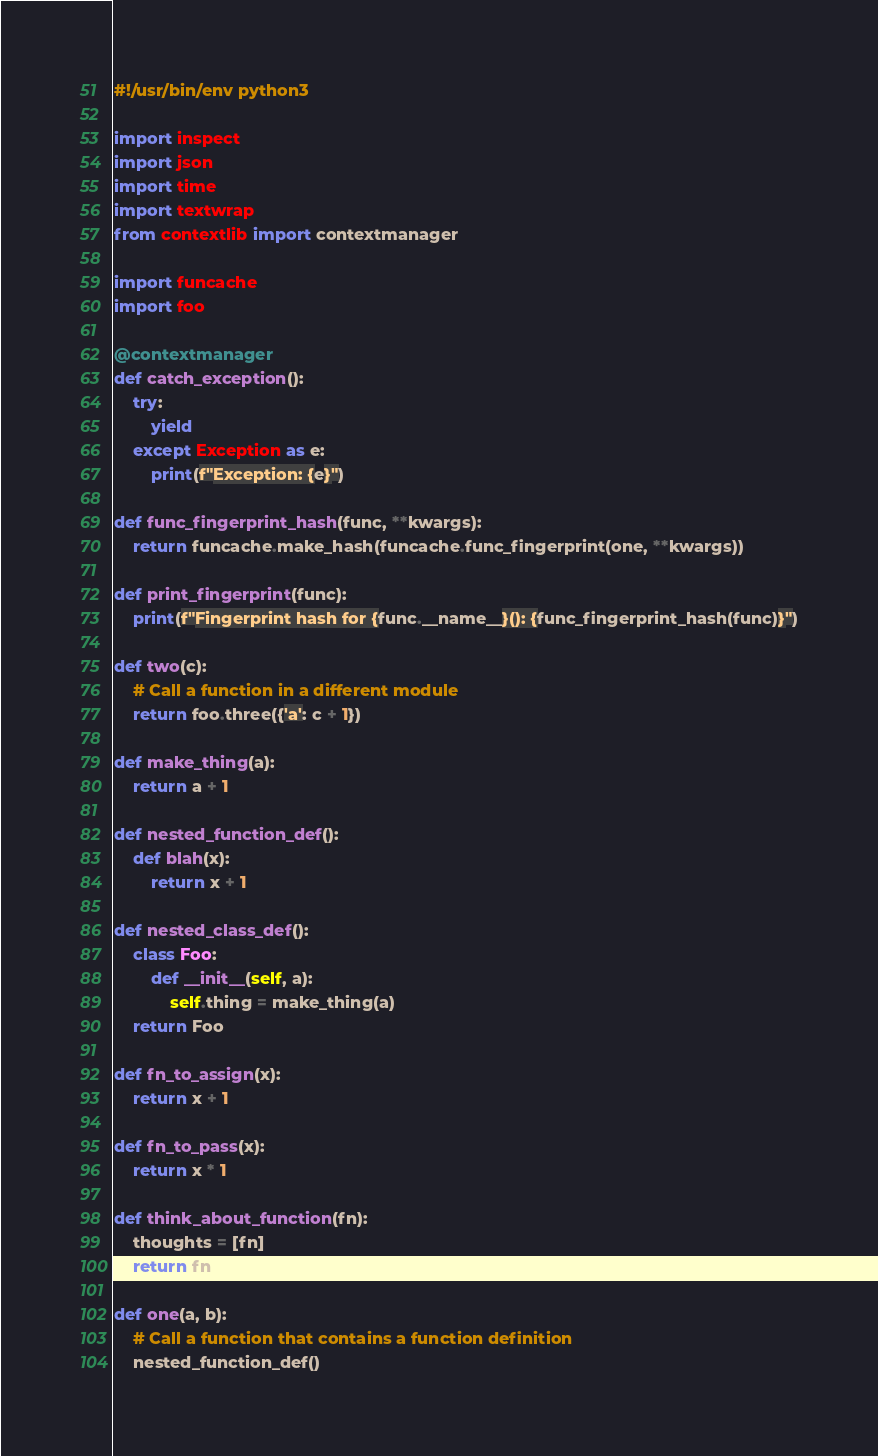Convert code to text. <code><loc_0><loc_0><loc_500><loc_500><_Python_>#!/usr/bin/env python3

import inspect
import json
import time
import textwrap
from contextlib import contextmanager

import funcache
import foo

@contextmanager
def catch_exception():
    try:
        yield
    except Exception as e:
        print(f"Exception: {e}")

def func_fingerprint_hash(func, **kwargs):
    return funcache.make_hash(funcache.func_fingerprint(one, **kwargs))

def print_fingerprint(func):
    print(f"Fingerprint hash for {func.__name__}(): {func_fingerprint_hash(func)}")

def two(c):
    # Call a function in a different module
    return foo.three({'a': c + 1})

def make_thing(a):
    return a + 1

def nested_function_def():
    def blah(x):
        return x + 1

def nested_class_def():
    class Foo:
        def __init__(self, a):
            self.thing = make_thing(a)
    return Foo

def fn_to_assign(x):
    return x + 1

def fn_to_pass(x):
    return x * 1

def think_about_function(fn):
    thoughts = [fn]
    return fn

def one(a, b):
    # Call a function that contains a function definition
    nested_function_def()</code> 